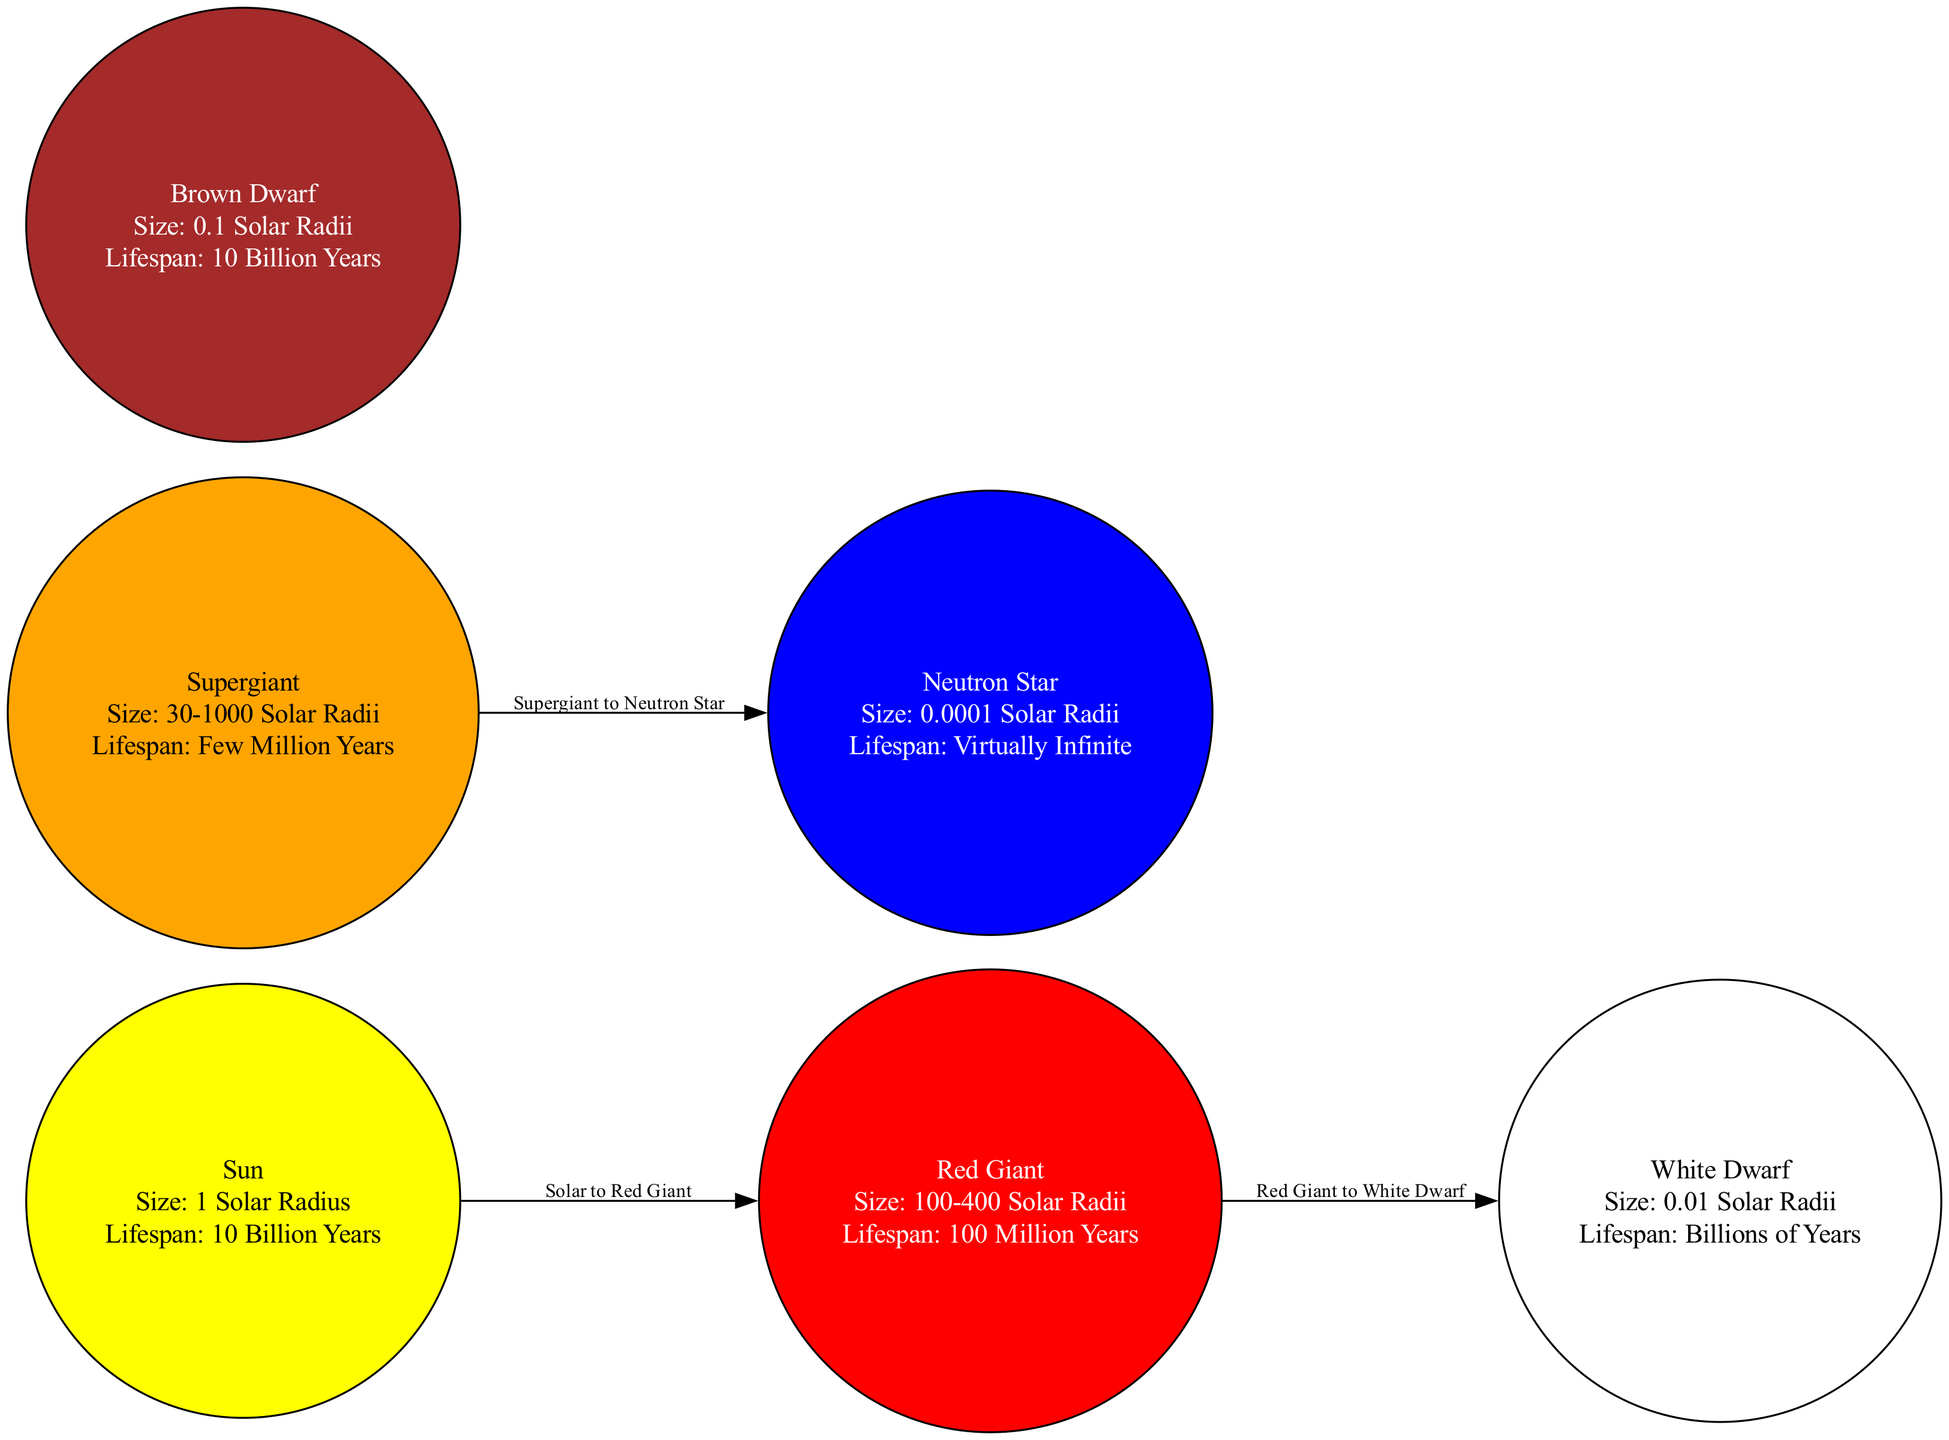What is the size of the Sun? The diagram specifies that the Sun has a size of "1 Solar Radius". This information is directly available in the node labeled "Sun".
Answer: 1 Solar Radius What is the lifespan of a Neutron Star? The Neutron Star node in the diagram indicates a lifespan of "Virtually Infinite". This detail is explicitly mentioned in the node's description.
Answer: Virtually Infinite How many nodes are in the diagram? By counting the distinct entities represented in the diagram, we find there are six nodes: Sun, Red Giant, White Dwarf, Supergiant, Neutron Star, and Brown Dwarf.
Answer: 6 What is the relationship labeled between the Red Giant and White Dwarf? The edge connecting the Red Giant to the White Dwarf is labeled "Red Giant to White Dwarf". This indicates a transformation or evolutionary stage in the lifecycle of stars.
Answer: Red Giant to White Dwarf Which star type is the largest by size? In the diagram, the Red Giant is shown to have a size range of "100-400 Solar Radii," which is the highest compared to others. Therefore, it is the largest type represented in the diagram.
Answer: Red Giant Which star has a lifespan comparable to the Sun? Both the Brown Dwarf and the Sun have a lifespan of "10 Billion Years," making them comparable in terms of longevity as indicated in their respective nodes.
Answer: Brown Dwarf What are the sizes of Supergiants? The diagram indicates that Supergiants range from "30-1000 Solar Radii". This size range clearly defines the scale of Supergiants as depicted in the diagram.
Answer: 30-1000 Solar Radii Which star has the smallest size? According to the diagram, the Neutron Star has a size of "0.0001 Solar Radii," making it the smallest star type presented.
Answer: 0.0001 Solar Radii What is the lifespan of a Red Giant? The lifespan indicated in the node for the Red Giant is "100 Million Years", which is explicitly mentioned in the diagram.
Answer: 100 Million Years 